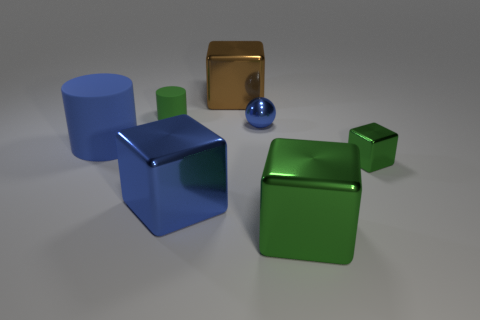There is a small green rubber object; is its shape the same as the small green object that is right of the big brown metal object?
Ensure brevity in your answer.  No. What color is the other tiny block that is made of the same material as the brown block?
Provide a succinct answer. Green. There is a blue metal thing behind the large matte cylinder; what is its size?
Your answer should be very brief. Small. Are there fewer big shiny blocks on the left side of the green rubber thing than blue shiny balls?
Offer a very short reply. Yes. Is the large cylinder the same color as the tiny cylinder?
Provide a succinct answer. No. Is there any other thing that is the same shape as the brown object?
Ensure brevity in your answer.  Yes. Are there fewer shiny balls than tiny cyan matte blocks?
Make the answer very short. No. The large metal block on the right side of the block behind the small cylinder is what color?
Keep it short and to the point. Green. What is the material of the green cube on the left side of the tiny green thing that is in front of the tiny thing that is behind the tiny shiny ball?
Provide a succinct answer. Metal. Do the metal block to the left of the brown thing and the tiny green rubber cylinder have the same size?
Ensure brevity in your answer.  No. 